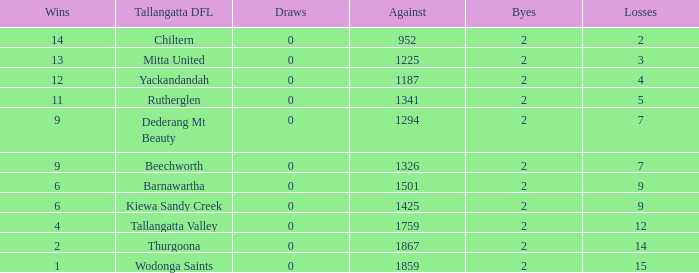What are the draws when wins are fwewer than 9 and byes fewer than 2? 0.0. 